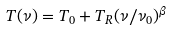Convert formula to latex. <formula><loc_0><loc_0><loc_500><loc_500>T ( \nu ) = T _ { 0 } + T _ { R } ( \nu / \nu _ { 0 } ) ^ { \beta }</formula> 